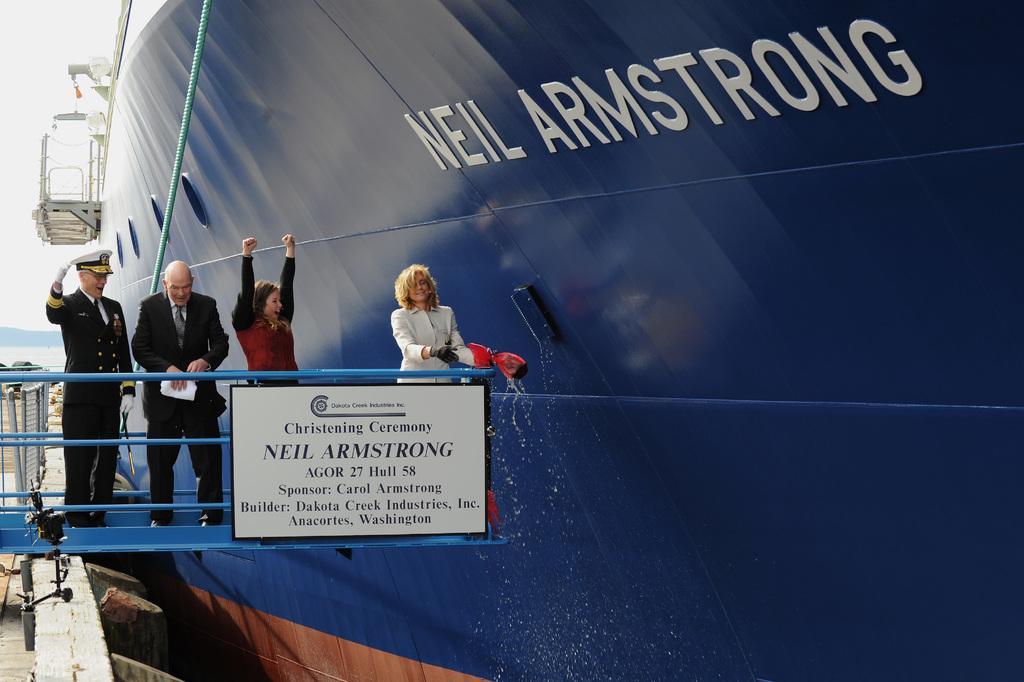Who or what can be seen in the image? There are people in the image. What object is present in the image that might be used for displaying information or messages? There is a board in the image. What type of vehicle is visible in the image? There is a ship in the image, although it appears to be truncated. What is written on the ship? Something is written on the ship. What part of the natural environment is visible in the image? There is sky visible on the left side of the image. What architectural feature can be seen on the left side of the image? There is a fence on the left side of the image. What level of the building are the birds perched on in the image? There are no birds present in the image. What process is being carried out by the people in the image? The provided facts do not give any information about a process being carried out by the people in the image. 